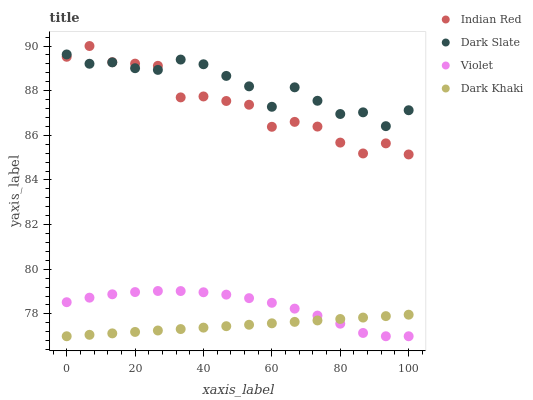Does Dark Khaki have the minimum area under the curve?
Answer yes or no. Yes. Does Dark Slate have the maximum area under the curve?
Answer yes or no. Yes. Does Indian Red have the minimum area under the curve?
Answer yes or no. No. Does Indian Red have the maximum area under the curve?
Answer yes or no. No. Is Dark Khaki the smoothest?
Answer yes or no. Yes. Is Indian Red the roughest?
Answer yes or no. Yes. Is Dark Slate the smoothest?
Answer yes or no. No. Is Dark Slate the roughest?
Answer yes or no. No. Does Dark Khaki have the lowest value?
Answer yes or no. Yes. Does Indian Red have the lowest value?
Answer yes or no. No. Does Indian Red have the highest value?
Answer yes or no. Yes. Does Dark Slate have the highest value?
Answer yes or no. No. Is Dark Khaki less than Indian Red?
Answer yes or no. Yes. Is Indian Red greater than Violet?
Answer yes or no. Yes. Does Violet intersect Dark Khaki?
Answer yes or no. Yes. Is Violet less than Dark Khaki?
Answer yes or no. No. Is Violet greater than Dark Khaki?
Answer yes or no. No. Does Dark Khaki intersect Indian Red?
Answer yes or no. No. 